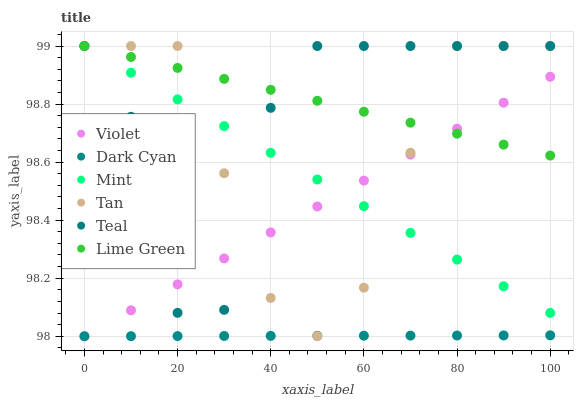Does Dark Cyan have the minimum area under the curve?
Answer yes or no. Yes. Does Lime Green have the maximum area under the curve?
Answer yes or no. Yes. Does Teal have the minimum area under the curve?
Answer yes or no. No. Does Teal have the maximum area under the curve?
Answer yes or no. No. Is Mint the smoothest?
Answer yes or no. Yes. Is Teal the roughest?
Answer yes or no. Yes. Is Teal the smoothest?
Answer yes or no. No. Is Violet the roughest?
Answer yes or no. No. Does Violet have the lowest value?
Answer yes or no. Yes. Does Teal have the lowest value?
Answer yes or no. No. Does Lime Green have the highest value?
Answer yes or no. Yes. Does Violet have the highest value?
Answer yes or no. No. Is Dark Cyan less than Mint?
Answer yes or no. Yes. Is Mint greater than Dark Cyan?
Answer yes or no. Yes. Does Tan intersect Mint?
Answer yes or no. Yes. Is Tan less than Mint?
Answer yes or no. No. Is Tan greater than Mint?
Answer yes or no. No. Does Dark Cyan intersect Mint?
Answer yes or no. No. 